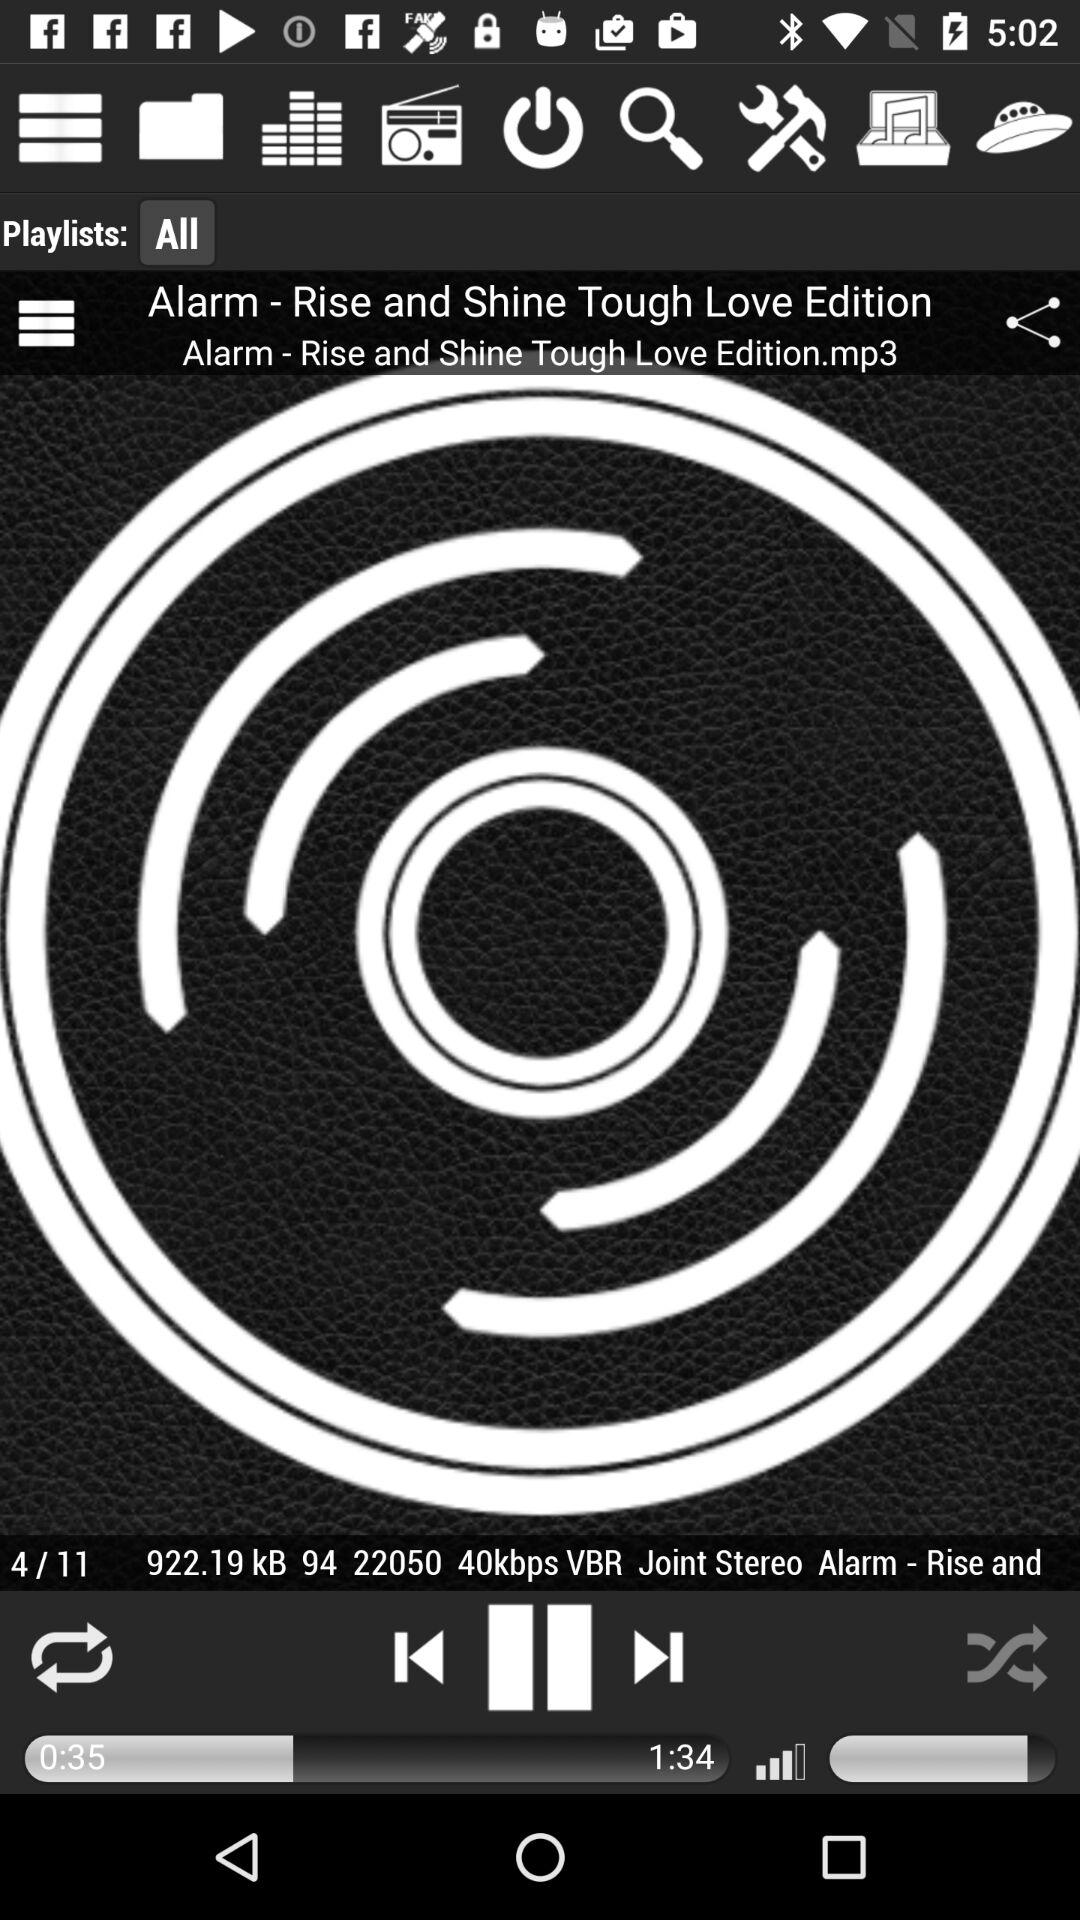How many seconds longer is the song than the current time?
Answer the question using a single word or phrase. 59 